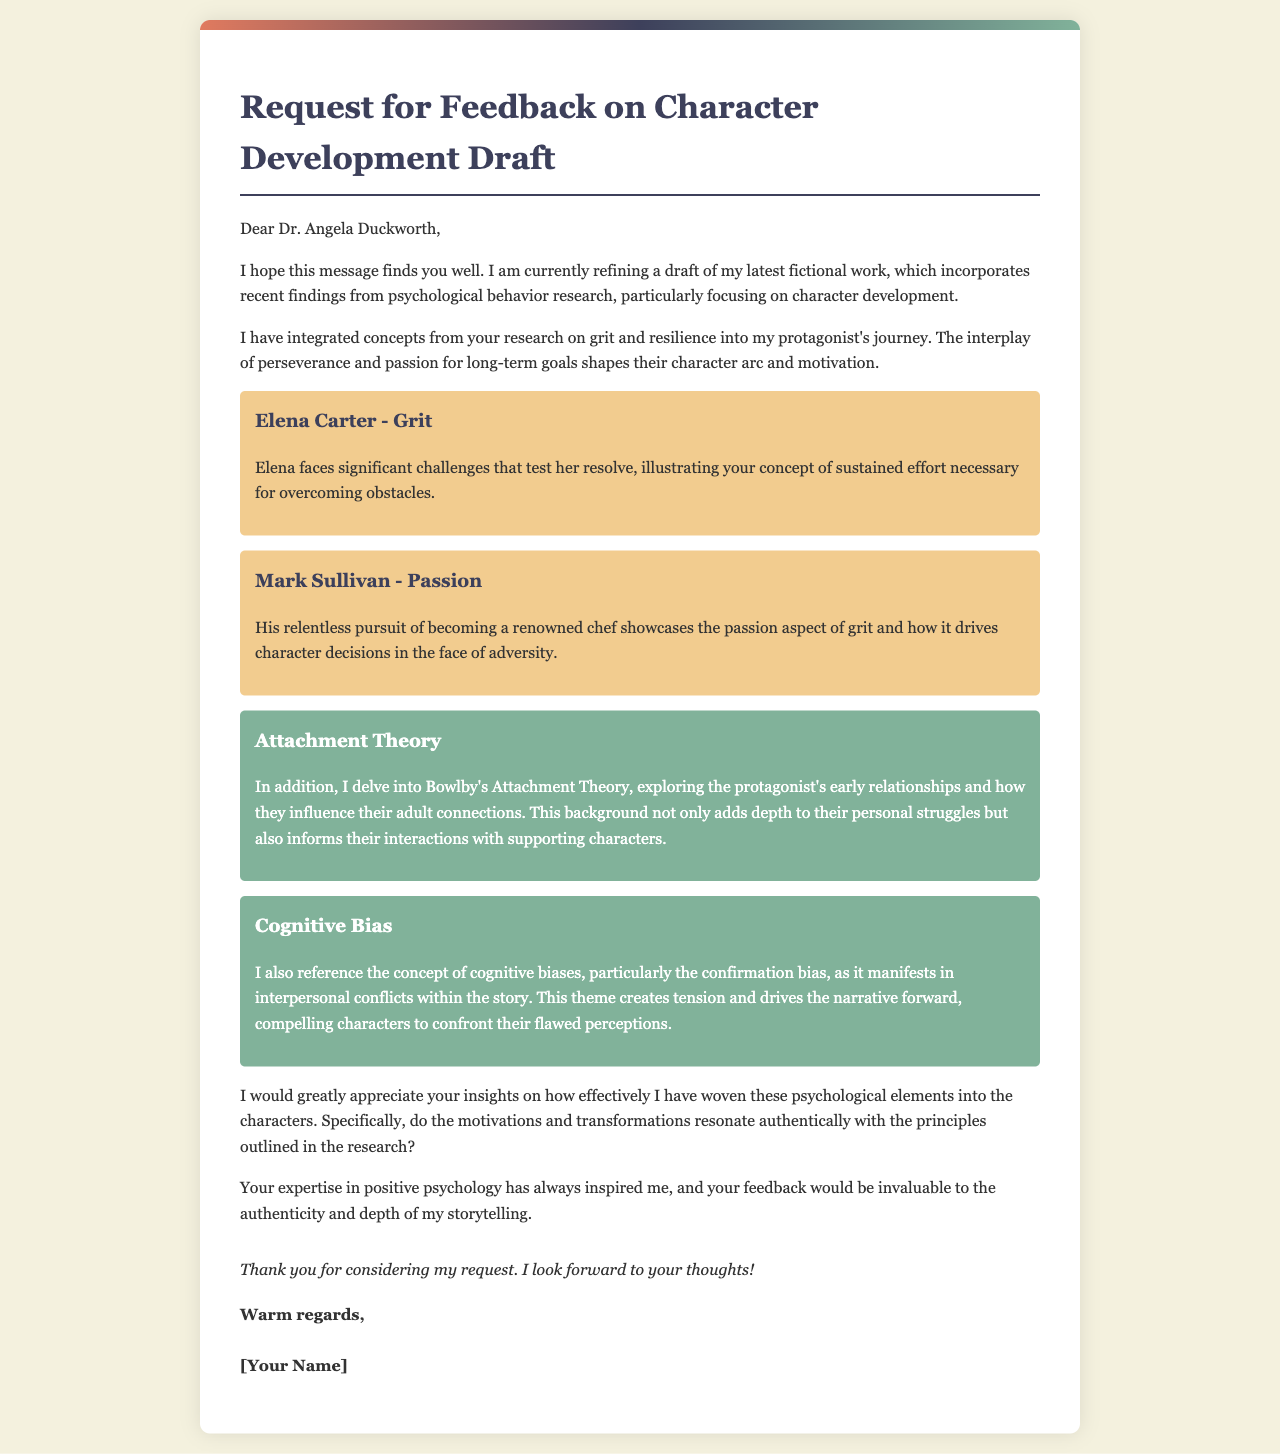What is the title of the letter? The title is indicated near the top of the letter.
Answer: Request for Feedback on Character Development Draft Who is the recipient of the letter? The recipient's name is mentioned directly in the greeting section of the letter.
Answer: Dr. Angela Duckworth What is the main topic addressed in the letter? The main topic is specified in the introduction of the document.
Answer: Character development draft Which psychological concept is exemplified by Elena Carter? The document outlines specific characters and the psychological concepts they embody.
Answer: Grit What theory is explored in relation to the protagonist's early relationships? The theory mentioned relates to how it influences adult connections in the story.
Answer: Attachment Theory What cognitive bias is referenced in the letter? The letter discusses a specific bias that affects interpersonal conflicts within the narrative.
Answer: Confirmation bias What is the author's request to the mentor? The request is made clear in one of the paragraphs of the letter.
Answer: Feedback on psychological elements What is the closing expression used in the letter? The closing expression is part of the final paragraph of the document.
Answer: Thank you for considering my request 